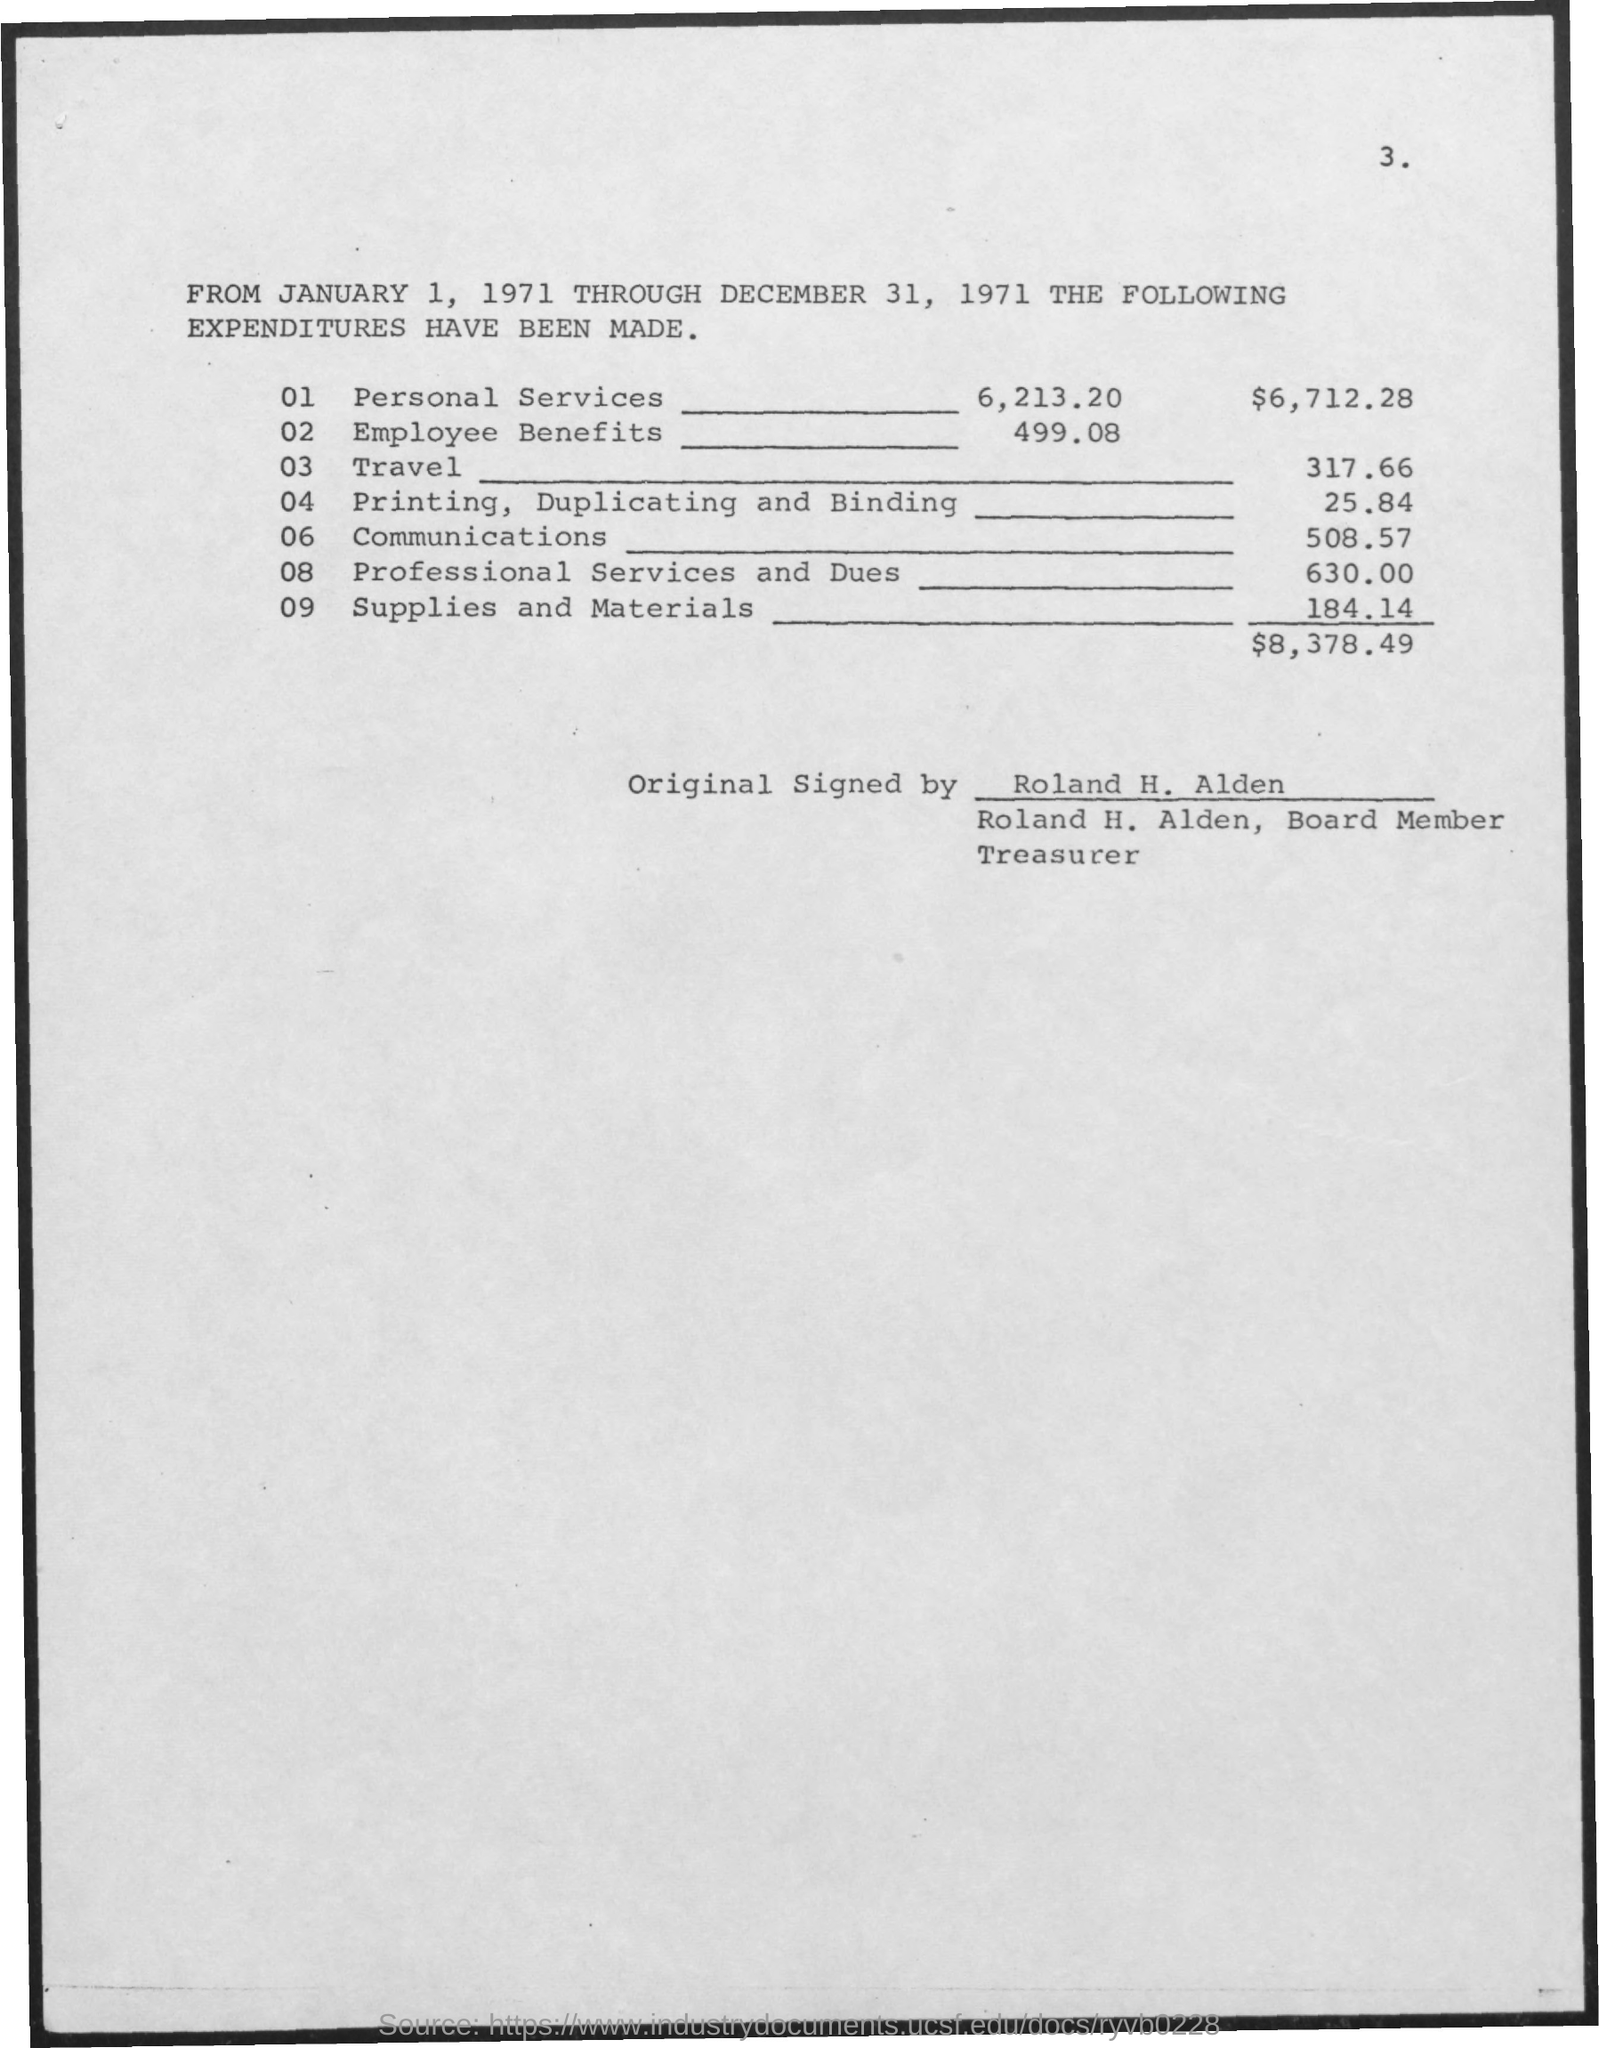Highlight a few significant elements in this photo. The expenditure for employee benefits is 499.08. The expenditure for supplies and materials is 184.14. The expenditures were made from January 1, 1971 to December 31, 1971. The expenditure for printing, duplicating, and binding is 25.84. The expenditure for travel is 317.66 dollars. 